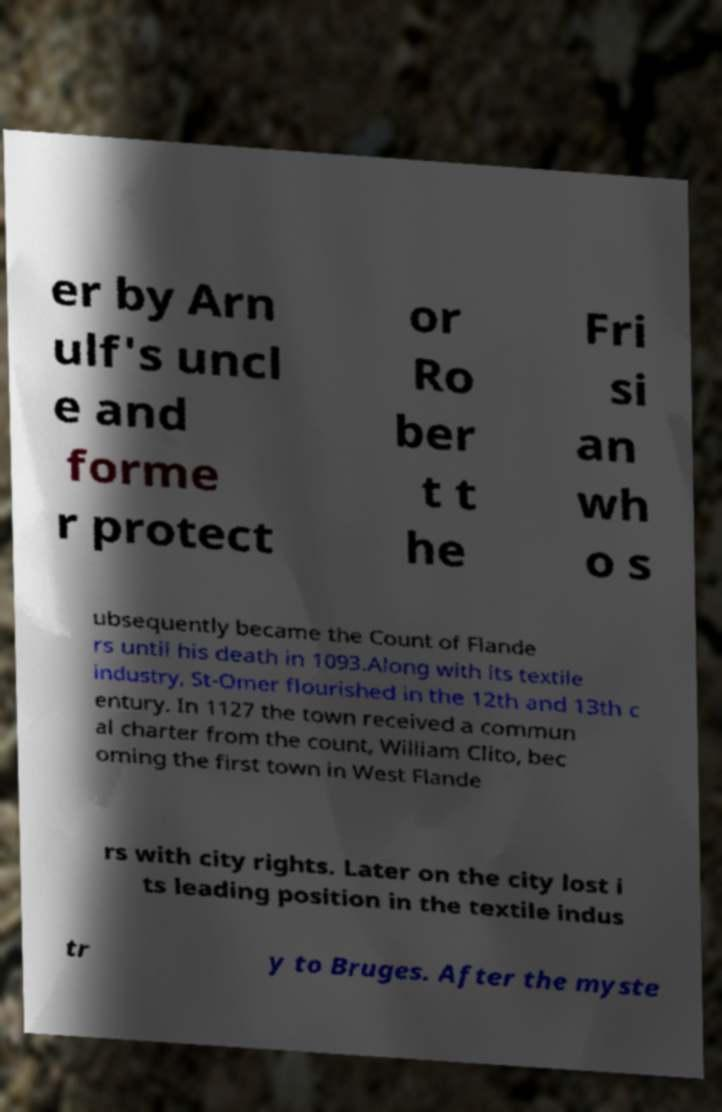For documentation purposes, I need the text within this image transcribed. Could you provide that? er by Arn ulf's uncl e and forme r protect or Ro ber t t he Fri si an wh o s ubsequently became the Count of Flande rs until his death in 1093.Along with its textile industry, St-Omer flourished in the 12th and 13th c entury. In 1127 the town received a commun al charter from the count, William Clito, bec oming the first town in West Flande rs with city rights. Later on the city lost i ts leading position in the textile indus tr y to Bruges. After the myste 